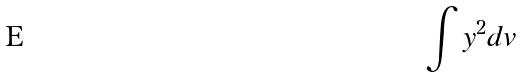Convert formula to latex. <formula><loc_0><loc_0><loc_500><loc_500>\int y ^ { 2 } d v</formula> 